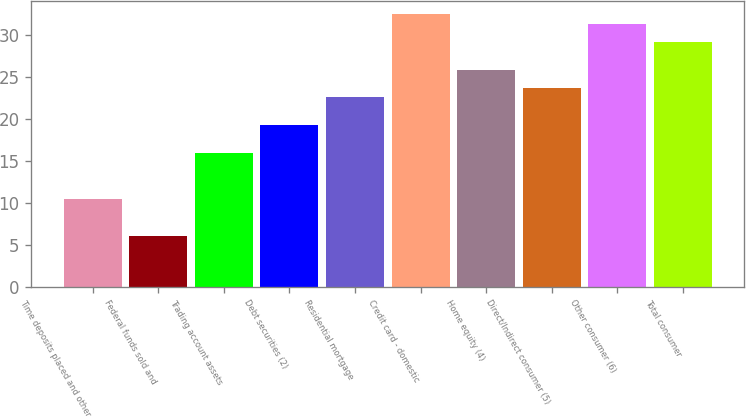<chart> <loc_0><loc_0><loc_500><loc_500><bar_chart><fcel>Time deposits placed and other<fcel>Federal funds sold and<fcel>Trading account assets<fcel>Debt securities (2)<fcel>Residential mortgage<fcel>Credit card - domestic<fcel>Home equity (4)<fcel>Direct/Indirect consumer (5)<fcel>Other consumer (6)<fcel>Total consumer<nl><fcel>10.48<fcel>6.08<fcel>15.98<fcel>19.28<fcel>22.58<fcel>32.48<fcel>25.88<fcel>23.68<fcel>31.38<fcel>29.18<nl></chart> 